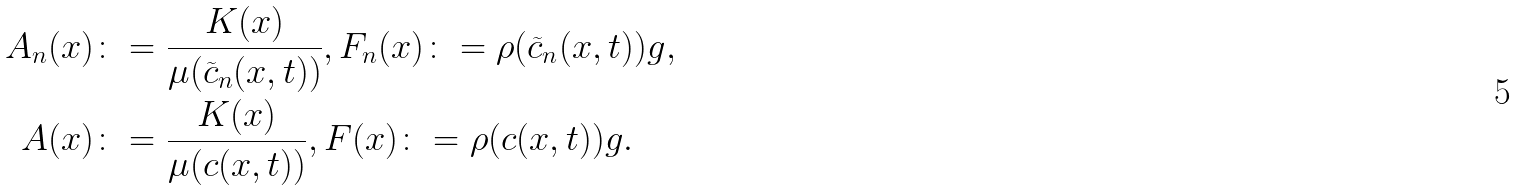<formula> <loc_0><loc_0><loc_500><loc_500>A _ { n } ( x ) & \colon = \frac { K ( x ) } { \mu ( \widetilde { c } _ { n } ( x , t ) ) } , F _ { n } ( x ) \colon = \rho ( \widetilde { c } _ { n } ( x , t ) ) g , \\ A ( x ) & \colon = \frac { K ( x ) } { \mu ( c ( x , t ) ) } , F ( x ) \colon = \rho ( c ( x , t ) ) g .</formula> 